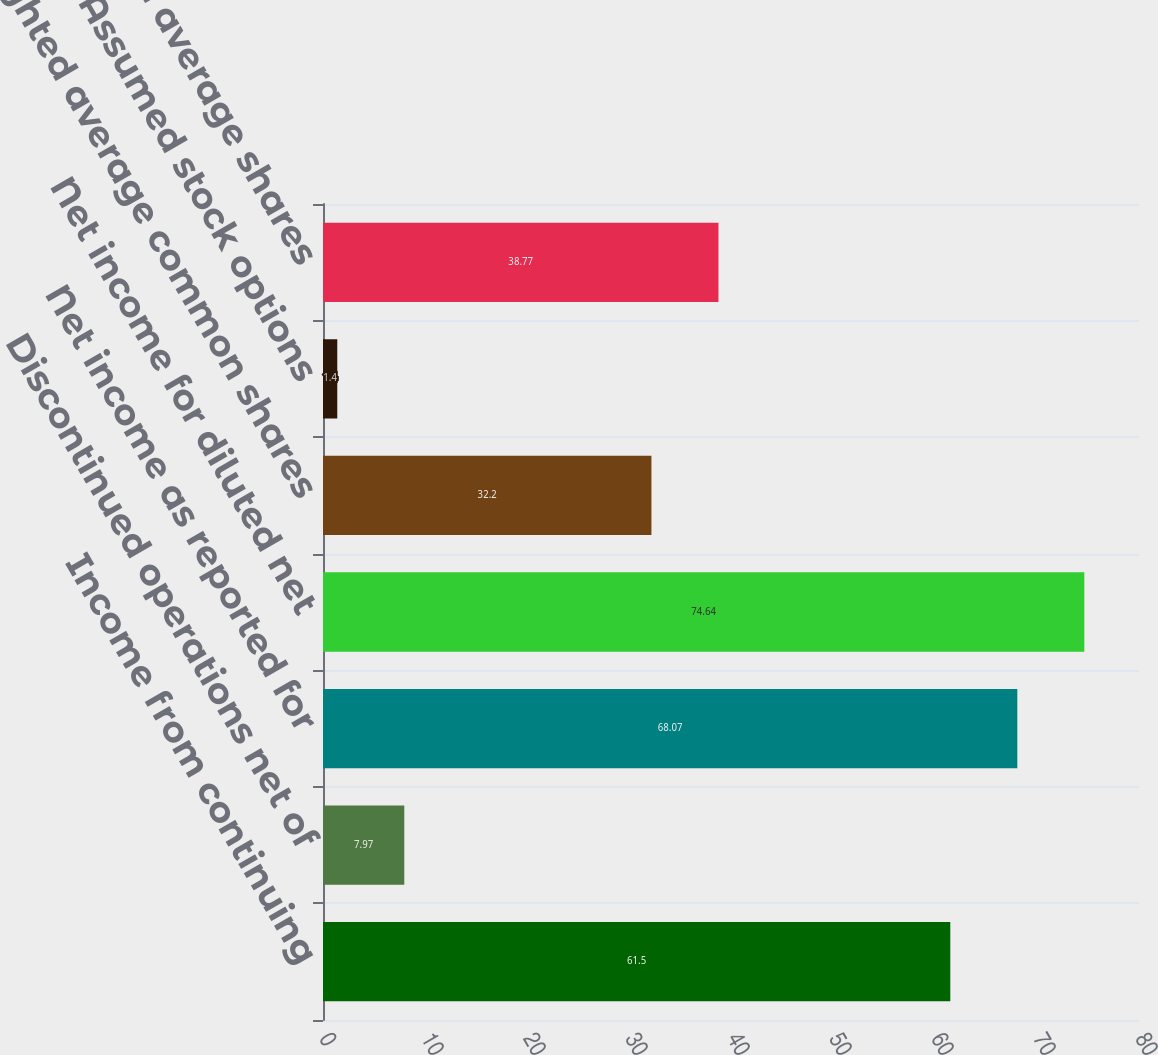Convert chart to OTSL. <chart><loc_0><loc_0><loc_500><loc_500><bar_chart><fcel>Income from continuing<fcel>Discontinued operations net of<fcel>Net income as reported for<fcel>Net income for diluted net<fcel>Weighted average common shares<fcel>Assumed stock options<fcel>Weighted average shares<nl><fcel>61.5<fcel>7.97<fcel>68.07<fcel>74.64<fcel>32.2<fcel>1.4<fcel>38.77<nl></chart> 